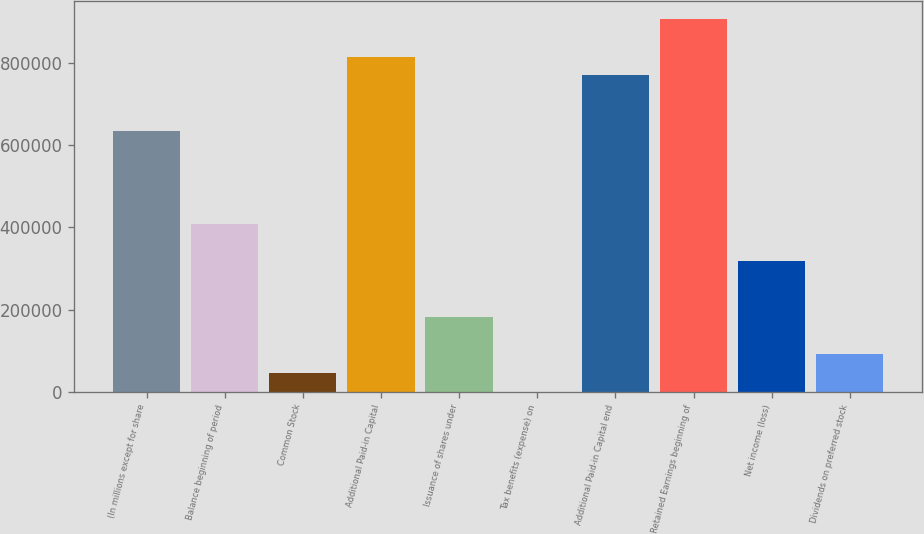<chart> <loc_0><loc_0><loc_500><loc_500><bar_chart><fcel>(In millions except for share<fcel>Balance beginning of period<fcel>Common Stock<fcel>Additional Paid-in Capital<fcel>Issuance of shares under<fcel>Tax benefits (expense) on<fcel>Additional Paid-in Capital end<fcel>Retained Earnings beginning of<fcel>Net income (loss)<fcel>Dividends on preferred stock<nl><fcel>634605<fcel>407961<fcel>45331.7<fcel>815920<fcel>181318<fcel>3<fcel>770591<fcel>906577<fcel>317304<fcel>90660.4<nl></chart> 